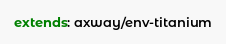Convert code to text. <code><loc_0><loc_0><loc_500><loc_500><_YAML_>extends: axway/env-titanium</code> 